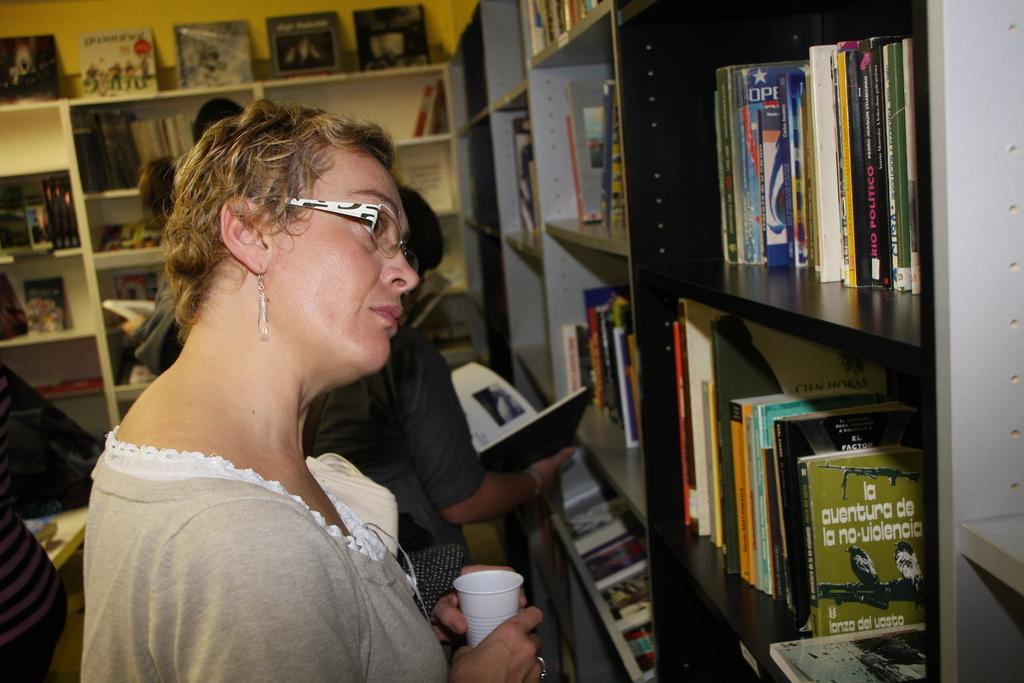<image>
Offer a succinct explanation of the picture presented. a lady is looking at books on a bookshelf, one of which says la auenture de la no violencia 